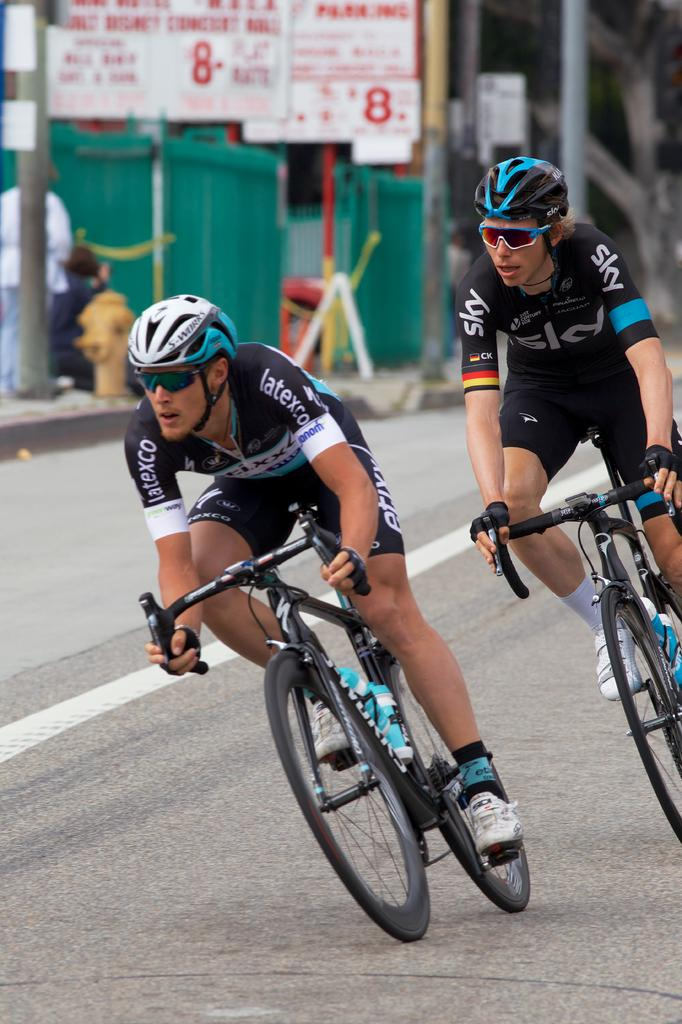What are the two people in the image doing? The two people in the image are riding bicycles. Where are the bicycles located? The bicycles are on a road. What can be seen in the background of the image? In the background of the image, there are people, boards, poles, and other objects. What statement can be made about the lake in the image? There is no lake present in the image. What type of selection is available for the people in the image? There is no selection mentioned or visible in the image. 